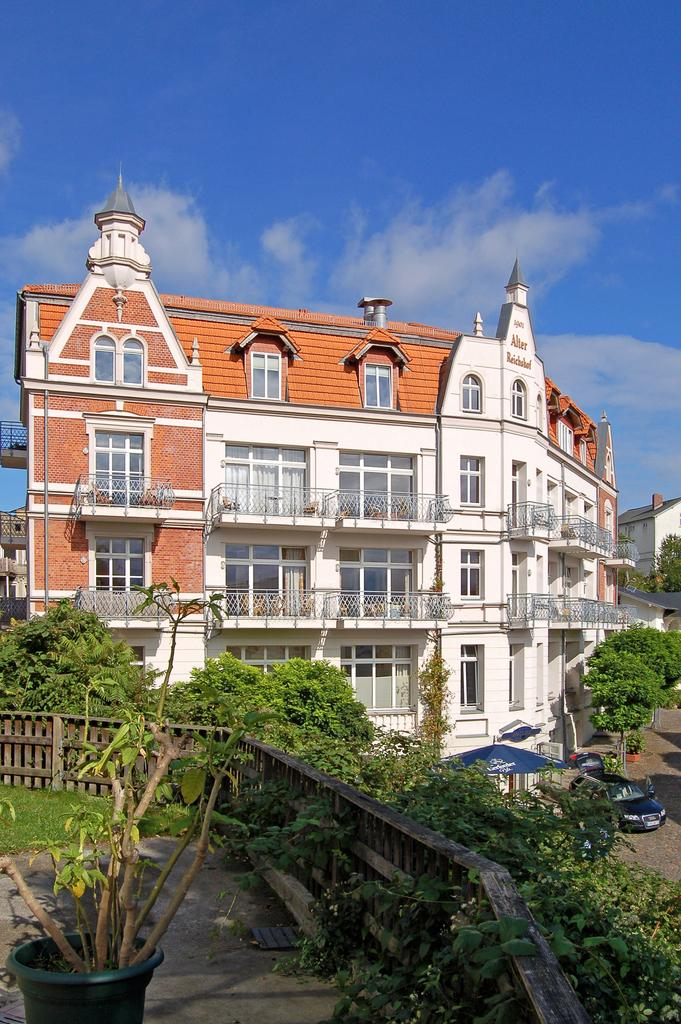What type of building is in the image? There is a big house in the image. What color is the house? The house is white in color. What can be seen on the right side of the image? There are vehicles parked on the right side of the image. What type of natural elements are present in the image? There are trees in the image. What is the color of the sky in the image? The sky is blue in color. How many plates are visible in the image? There are no plates visible in the image. What type of car is parked on the right side of the image? The provided facts do not mention any specific type of car; only vehicles are mentioned. 